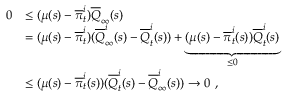<formula> <loc_0><loc_0><loc_500><loc_500>\begin{array} { r l } { 0 } & { \leq ( \mu ( s ) - \overline { \pi } _ { t } ^ { i } ) \overline { Q } _ { \infty } ( s ) } \\ & { = ( \mu ( s ) - \overline { \pi } _ { t } ^ { i } ) ( \overline { Q } _ { \infty } ^ { i } ( s ) - \overline { Q } _ { t } ^ { i } ( s ) ) + \underbrace { ( \mu ( s ) - \overline { \pi } _ { t } ^ { i } ( s ) ) \overline { Q } _ { t } ^ { i } ( s ) } _ { \leq 0 } } \\ & { \leq ( \mu ( s ) - \overline { \pi } _ { t } ^ { i } ( s ) ) ( \overline { Q } _ { t } ^ { i } ( s ) - \overline { Q } _ { \infty } ^ { i } ( s ) ) \rightarrow 0 \ , } \end{array}</formula> 